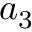Convert formula to latex. <formula><loc_0><loc_0><loc_500><loc_500>a _ { 3 }</formula> 